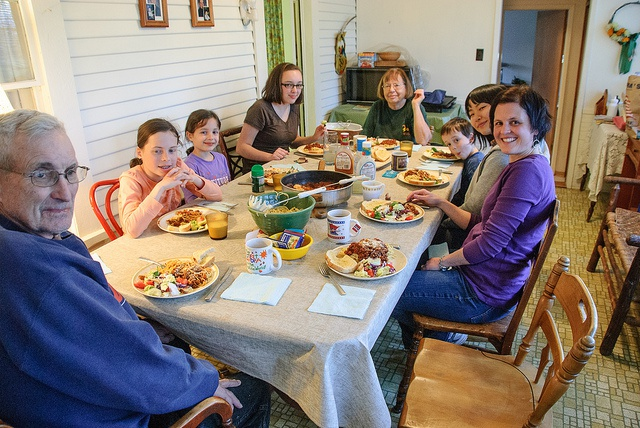Describe the objects in this image and their specific colors. I can see dining table in lightgray, tan, and darkgray tones, people in lightgray, navy, black, and blue tones, people in lightgray, navy, black, purple, and brown tones, chair in lightgray, brown, tan, maroon, and olive tones, and people in lightgray, lightpink, tan, and brown tones in this image. 